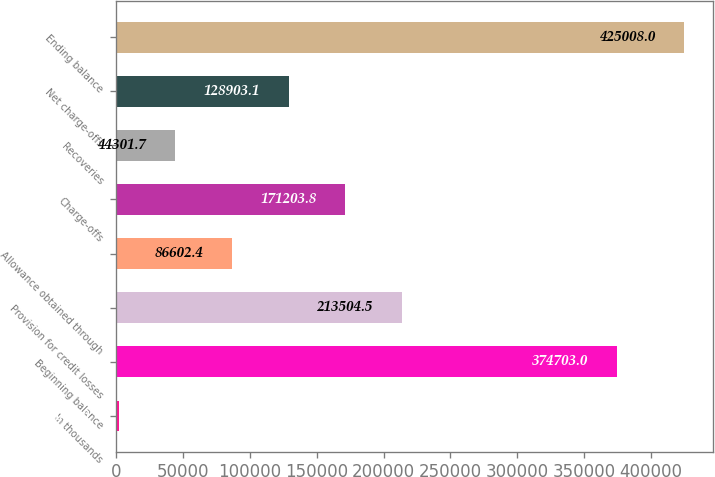Convert chart. <chart><loc_0><loc_0><loc_500><loc_500><bar_chart><fcel>In thousands<fcel>Beginning balance<fcel>Provision for credit losses<fcel>Allowance obtained through<fcel>Charge-offs<fcel>Recoveries<fcel>Net charge-offs<fcel>Ending balance<nl><fcel>2001<fcel>374703<fcel>213504<fcel>86602.4<fcel>171204<fcel>44301.7<fcel>128903<fcel>425008<nl></chart> 